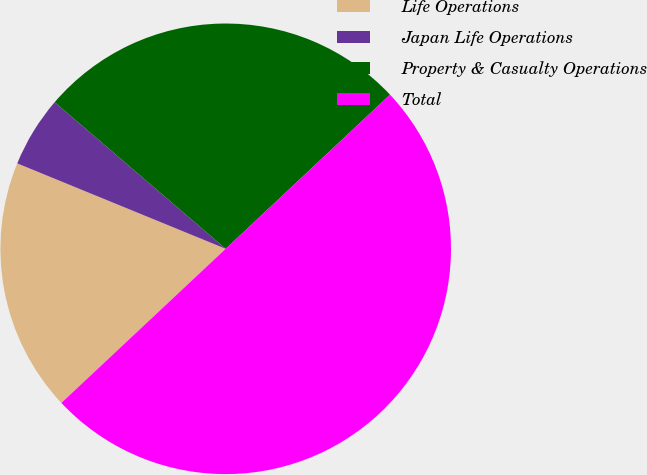Convert chart. <chart><loc_0><loc_0><loc_500><loc_500><pie_chart><fcel>Life Operations<fcel>Japan Life Operations<fcel>Property & Casualty Operations<fcel>Total<nl><fcel>18.18%<fcel>5.09%<fcel>26.73%<fcel>50.0%<nl></chart> 